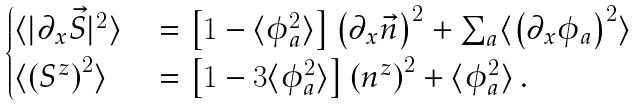Convert formula to latex. <formula><loc_0><loc_0><loc_500><loc_500>\begin{cases} \langle | \partial _ { x } \vec { S } | ^ { 2 } \rangle \, & = \left [ 1 - \langle \phi _ { a } ^ { 2 } \rangle \right ] \left ( \partial _ { x } \vec { n } \right ) ^ { 2 } + \sum _ { a } \langle \left ( \partial _ { x } \phi _ { a } \right ) ^ { 2 } \rangle \\ \langle \left ( S ^ { z } \right ) ^ { 2 } \rangle \, & = \left [ 1 - 3 \langle \phi _ { a } ^ { 2 } \rangle \right ] \left ( n ^ { z } \right ) ^ { 2 } + \langle \phi _ { a } ^ { 2 } \rangle \, . \end{cases}</formula> 